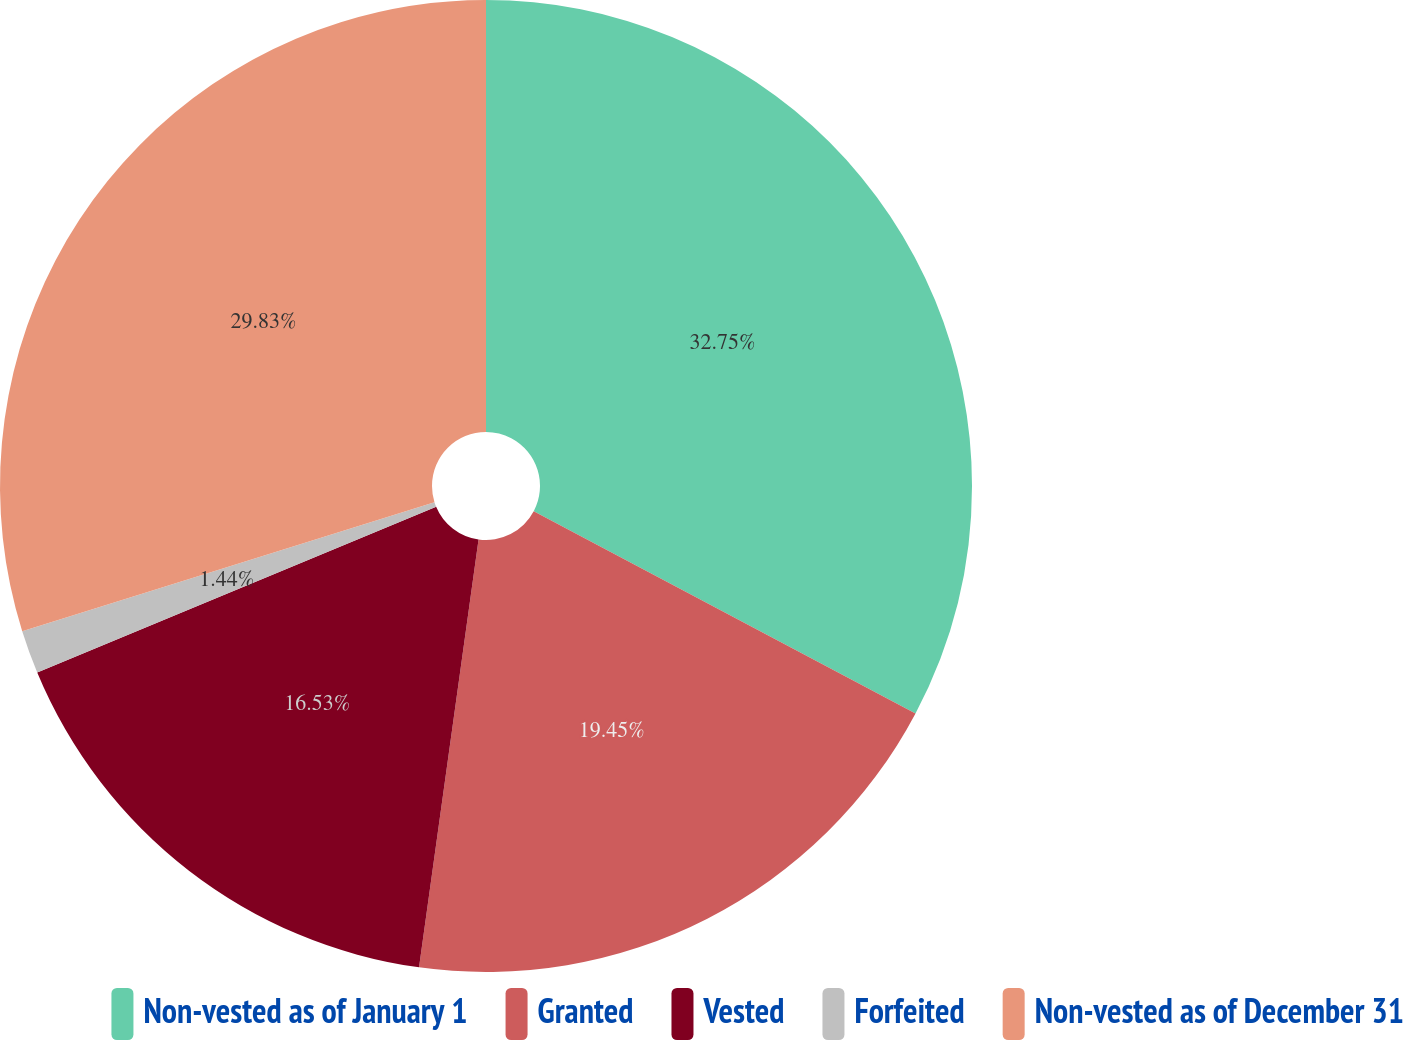Convert chart. <chart><loc_0><loc_0><loc_500><loc_500><pie_chart><fcel>Non-vested as of January 1<fcel>Granted<fcel>Vested<fcel>Forfeited<fcel>Non-vested as of December 31<nl><fcel>32.75%<fcel>19.45%<fcel>16.53%<fcel>1.44%<fcel>29.83%<nl></chart> 